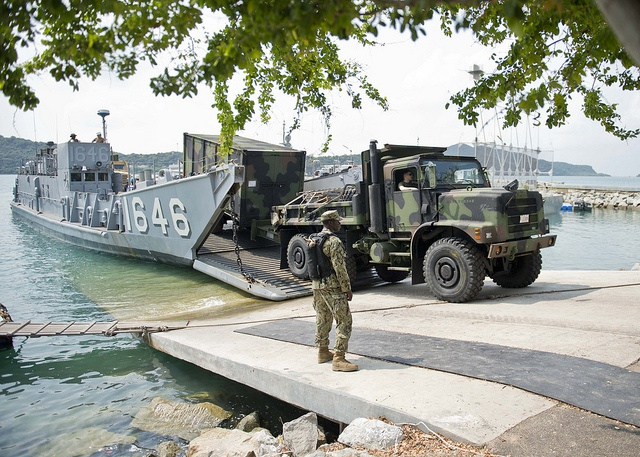Describe the objects in this image and their specific colors. I can see truck in black, gray, darkgray, and lightgray tones, boat in black, darkgray, gray, and lightgray tones, people in black, gray, and darkgreen tones, backpack in black, gray, darkgray, and lightgray tones, and boat in black, darkgray, gray, and lightgray tones in this image. 